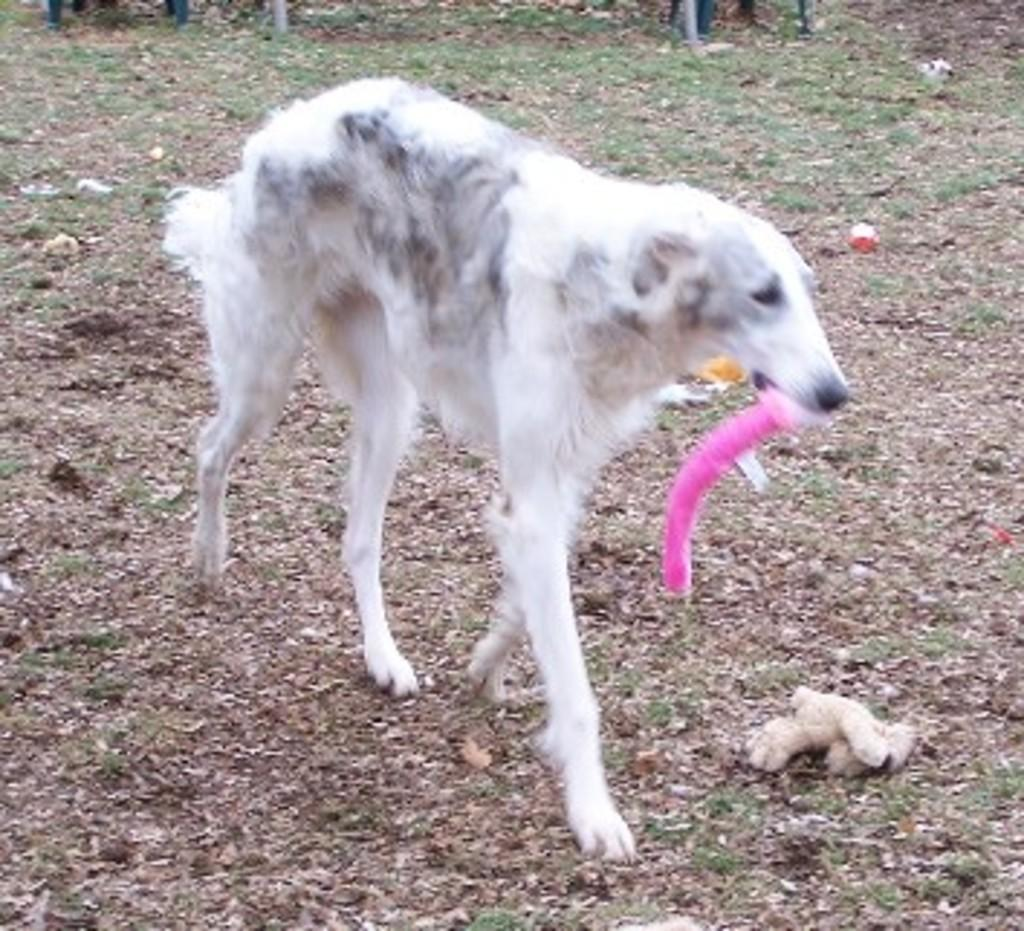What type of animal is in the image? There is a dog in the image. What color is the dog? The dog is white in color. What is the dog doing in the image? The dog is holding something in its mouth. What can be seen in the background of the image? There is grass in the background of the image, but it is blurred. What type of eggnog is the dog drinking in the image? There is no eggnog present in the image; the dog is holding something in its mouth, but it is not mentioned as being eggnog. 